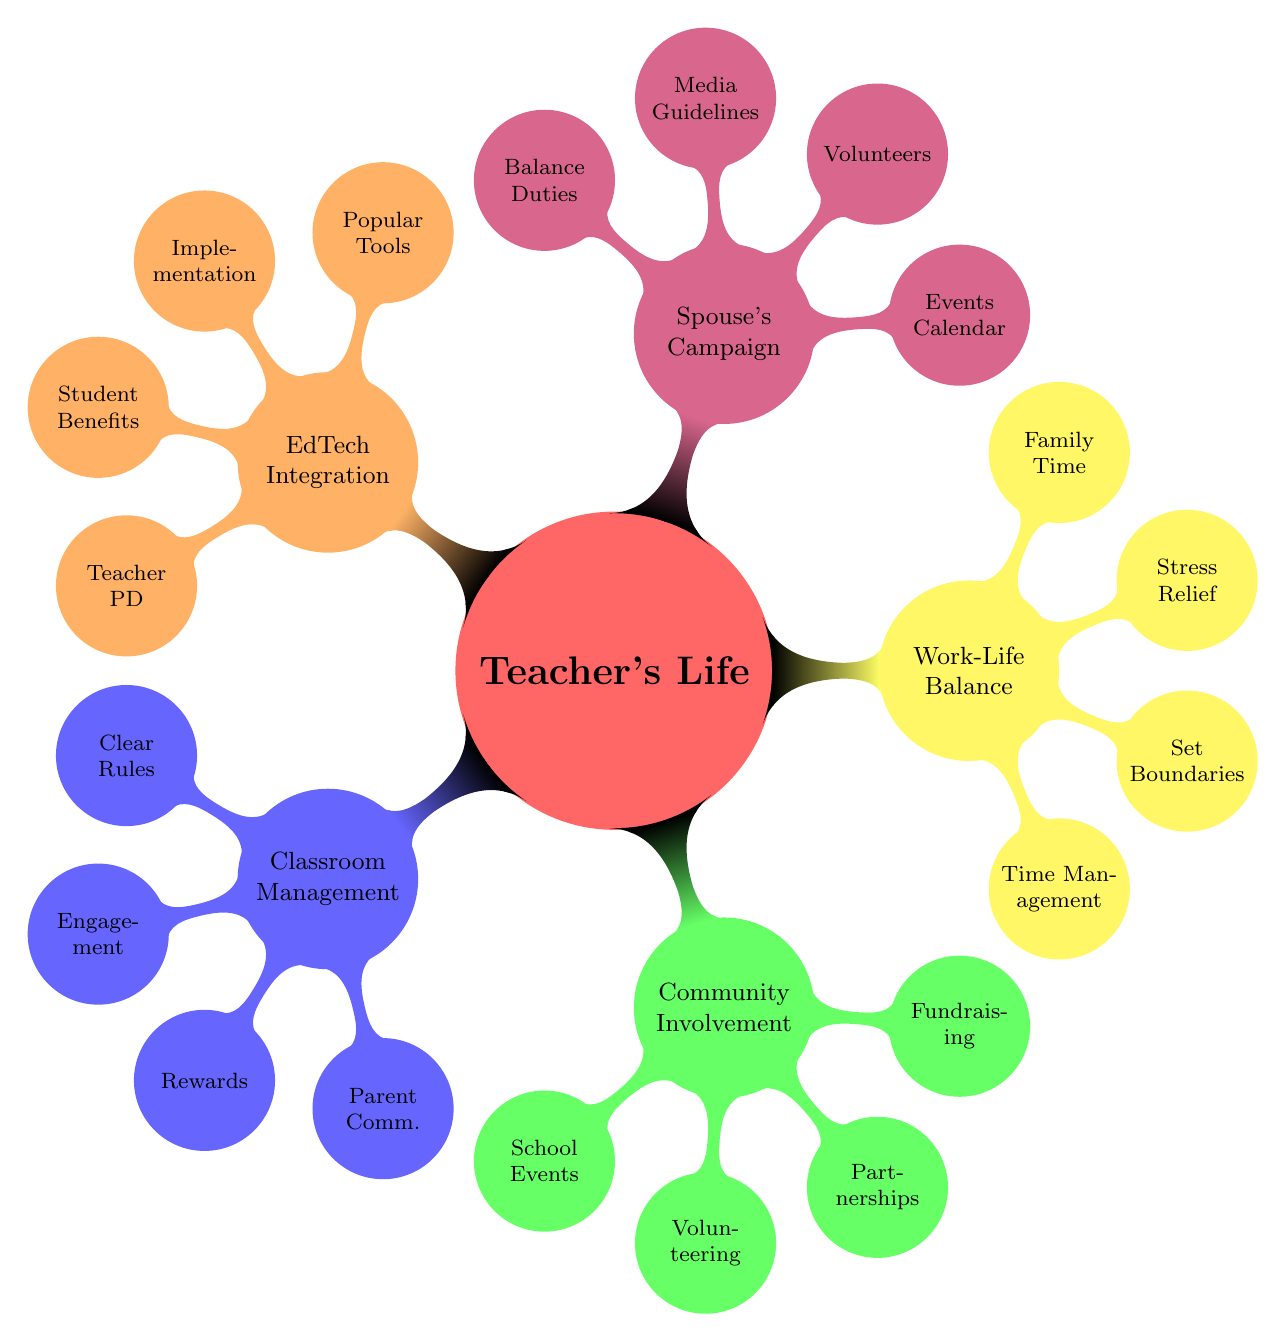What are the main categories in the mind map? The main categories are the five main nodes stemming from the central concept, which include Classroom Management, Community Involvement, Work-Life Balance, Spouse's Campaign, and EdTech Integration.
Answer: Classroom Management, Community Involvement, Work-Life Balance, Spouse's Campaign, EdTech Integration How many nodes are listed under Classroom Management Strategies? Under Classroom Management, there are four nodes: Techniques for Maintaining Order, Student Engagement Methods, Reward Systems, and Parent-Teacher Communication. Counting them brings the total to four.
Answer: 4 What color represents Community Involvement? The mind map uses a green color scheme to signify Community Involvement, as shown in the diagram where this category is highlighted.
Answer: Green Which strategy is listed first under Balancing Professional and Personal Life? The first listed strategy in the Balancing Professional and Personal Life is Time Management Tips, as the nodes are organized in a specific order starting from the top.
Answer: Time Management How many volunteer coordination methods are listed under Supporting Spouse's Campaign? There are three methods listed for volunteer coordination: Volunteer Sign-up Sheets, Regular Briefings, and Task Assignments, counted individually brings the total to three.
Answer: 3 What is the relationship between EdTech Integration and Teacher Professional Development Resources? Teacher Professional Development Resources is a sub-node of EdTech Integration, indicating that they fall under the broader category of EdTech approaches relevant for teachers.
Answer: Sub-node Identify one student engagement method listed in the diagram. One example of a student engagement method under the Student Engagement Methods node is Interactive Lessons, which illustrates a technique to engage students in the classroom.
Answer: Interactive Lessons Which campaign element is included in the Spouse's Campaign category? The Events Calendar is one of the elements included in the Spouse's Campaign category, highlighting the importance of scheduling for campaign activities.
Answer: Events Calendar What tool is mentioned as a popular EdTech tool? Google Classroom is specifically named under the Popular EdTech Tools, reflecting its prominence among educational technologies used in teaching.
Answer: Google Classroom 